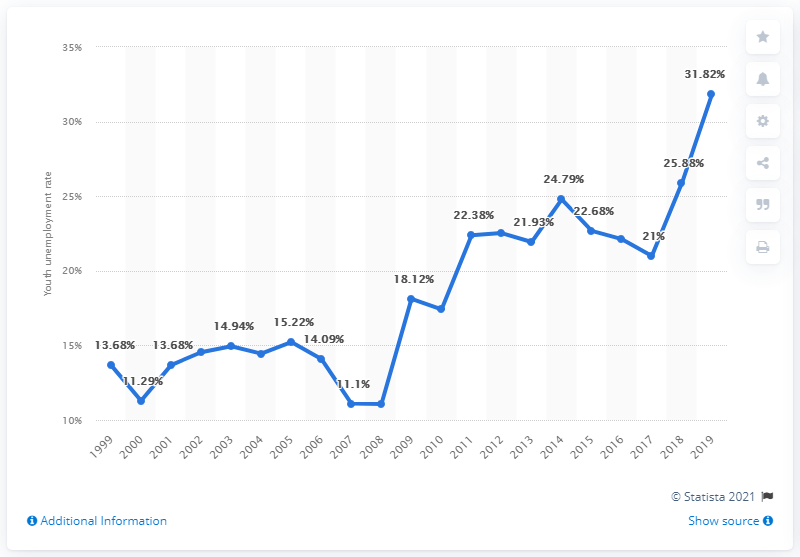Specify some key components in this picture. In 2019, the youth unemployment rate in Costa Rica was 31.82%. 